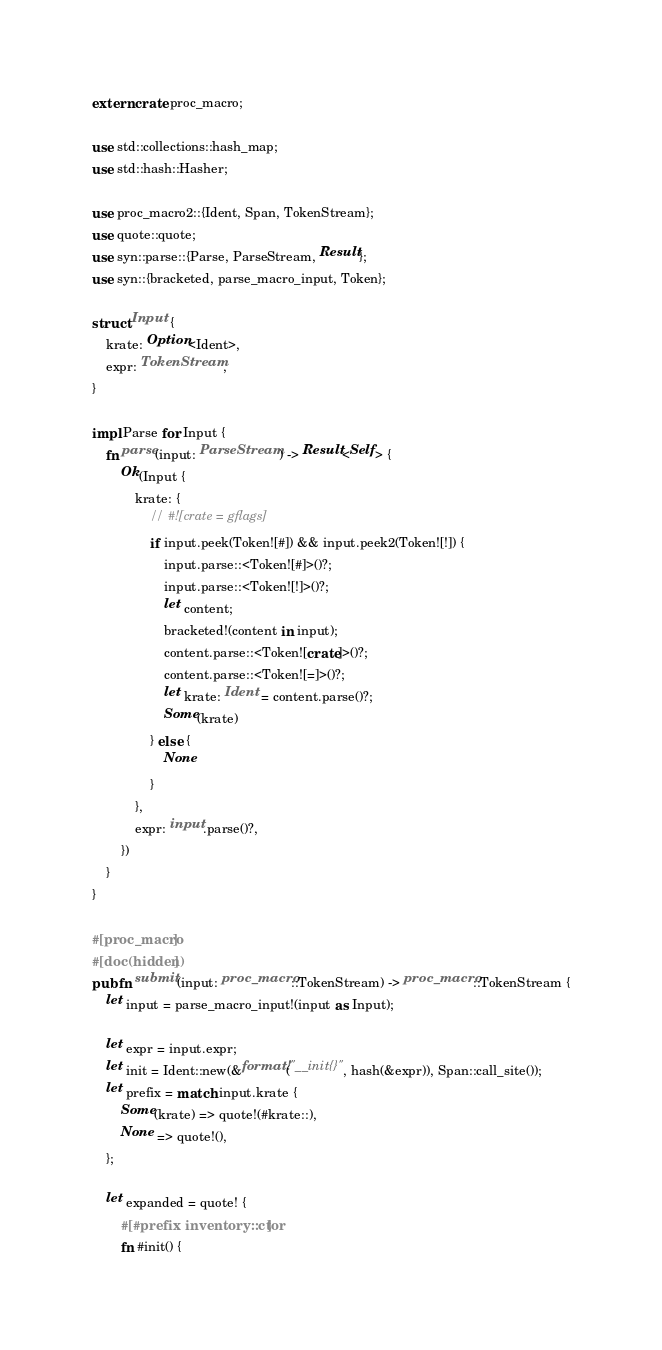<code> <loc_0><loc_0><loc_500><loc_500><_Rust_>extern crate proc_macro;

use std::collections::hash_map;
use std::hash::Hasher;

use proc_macro2::{Ident, Span, TokenStream};
use quote::quote;
use syn::parse::{Parse, ParseStream, Result};
use syn::{bracketed, parse_macro_input, Token};

struct Input {
    krate: Option<Ident>,
    expr: TokenStream,
}

impl Parse for Input {
    fn parse(input: ParseStream) -> Result<Self> {
        Ok(Input {
            krate: {
                // #![crate = gflags]
                if input.peek(Token![#]) && input.peek2(Token![!]) {
                    input.parse::<Token![#]>()?;
                    input.parse::<Token![!]>()?;
                    let content;
                    bracketed!(content in input);
                    content.parse::<Token![crate]>()?;
                    content.parse::<Token![=]>()?;
                    let krate: Ident = content.parse()?;
                    Some(krate)
                } else {
                    None
                }
            },
            expr: input.parse()?,
        })
    }
}

#[proc_macro]
#[doc(hidden)]
pub fn submit(input: proc_macro::TokenStream) -> proc_macro::TokenStream {
    let input = parse_macro_input!(input as Input);

    let expr = input.expr;
    let init = Ident::new(&format!("__init{}", hash(&expr)), Span::call_site());
    let prefix = match input.krate {
        Some(krate) => quote!(#krate::),
        None => quote!(),
    };

    let expanded = quote! {
        #[#prefix inventory::ctor]
        fn #init() {</code> 